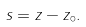Convert formula to latex. <formula><loc_0><loc_0><loc_500><loc_500>s = z - z _ { \circ } .</formula> 